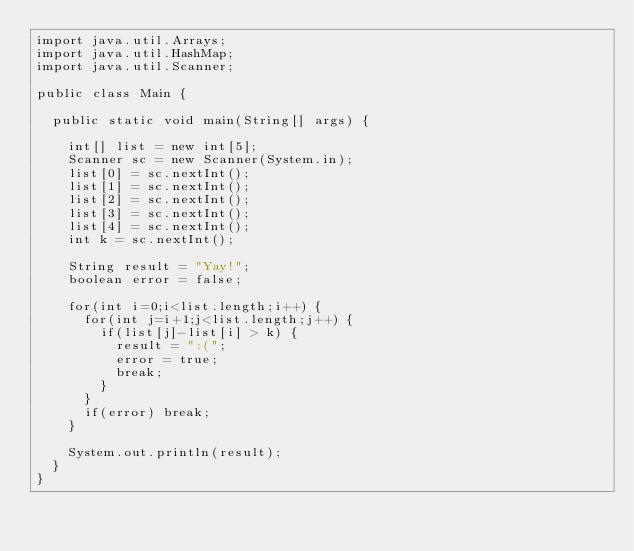Convert code to text. <code><loc_0><loc_0><loc_500><loc_500><_Java_>import java.util.Arrays;
import java.util.HashMap;
import java.util.Scanner;

public class Main {

	public static void main(String[] args) {
		
		int[] list = new int[5];
		Scanner sc = new Scanner(System.in);
		list[0] = sc.nextInt();
		list[1] = sc.nextInt();
		list[2] = sc.nextInt();
		list[3] = sc.nextInt();
		list[4] = sc.nextInt();
		int k = sc.nextInt();
      
		String result = "Yay!";
		boolean error = false;
		
		for(int i=0;i<list.length;i++) {
			for(int j=i+1;j<list.length;j++) {
				if(list[j]-list[i] > k) {
					result = ":(";
					error = true;
					break;
				}
			}
			if(error) break;
		}
		
		System.out.println(result);
	}
}
</code> 